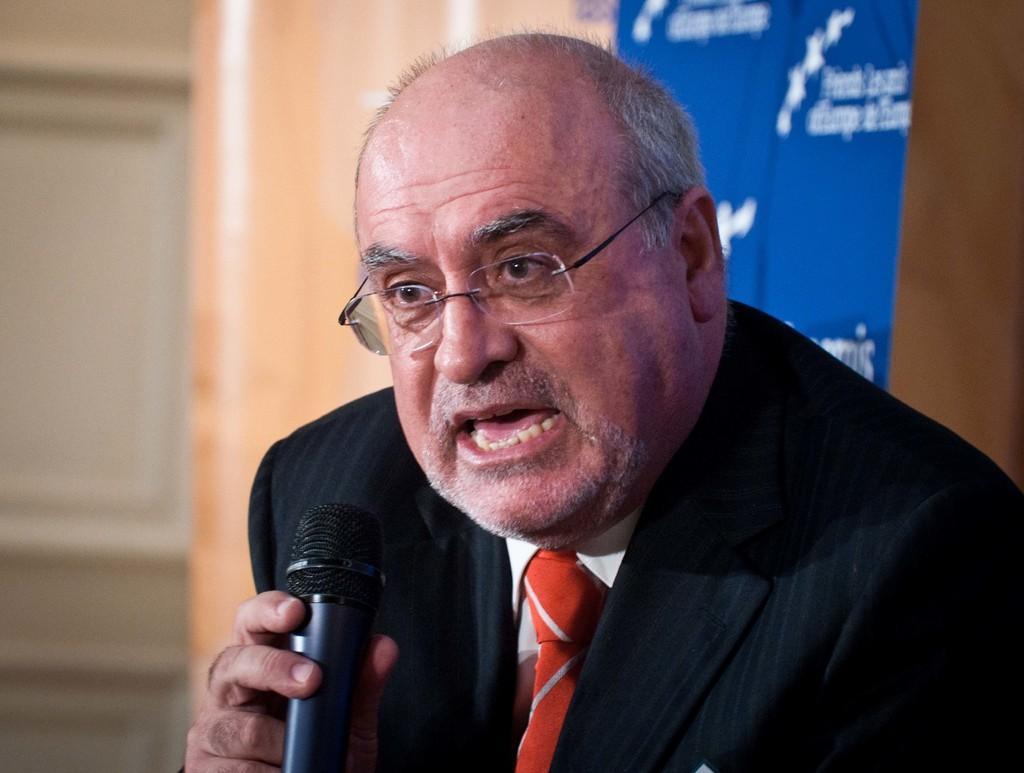Who is the main subject in the image? There is a man in the image. What is the man wearing? The man is wearing a blazer and spectacles. What is the man holding in his hand? The man is holding a microphone in his hand. What might the man be doing in the image? The man appears to be talking, possibly giving a speech or presentation. What can be seen in the background of the image? There is a wall and a banner in the background of the image. What type of attraction can be seen in the background of the image? There is no attraction visible in the background of the image; it only shows a wall and a banner. What thrilling activity is the man participating in while wearing the blazer? There is no thrilling activity depicted in the image; the man is simply holding a microphone and appears to be talking. 